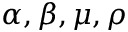<formula> <loc_0><loc_0><loc_500><loc_500>\alpha , \beta , \mu , \rho</formula> 